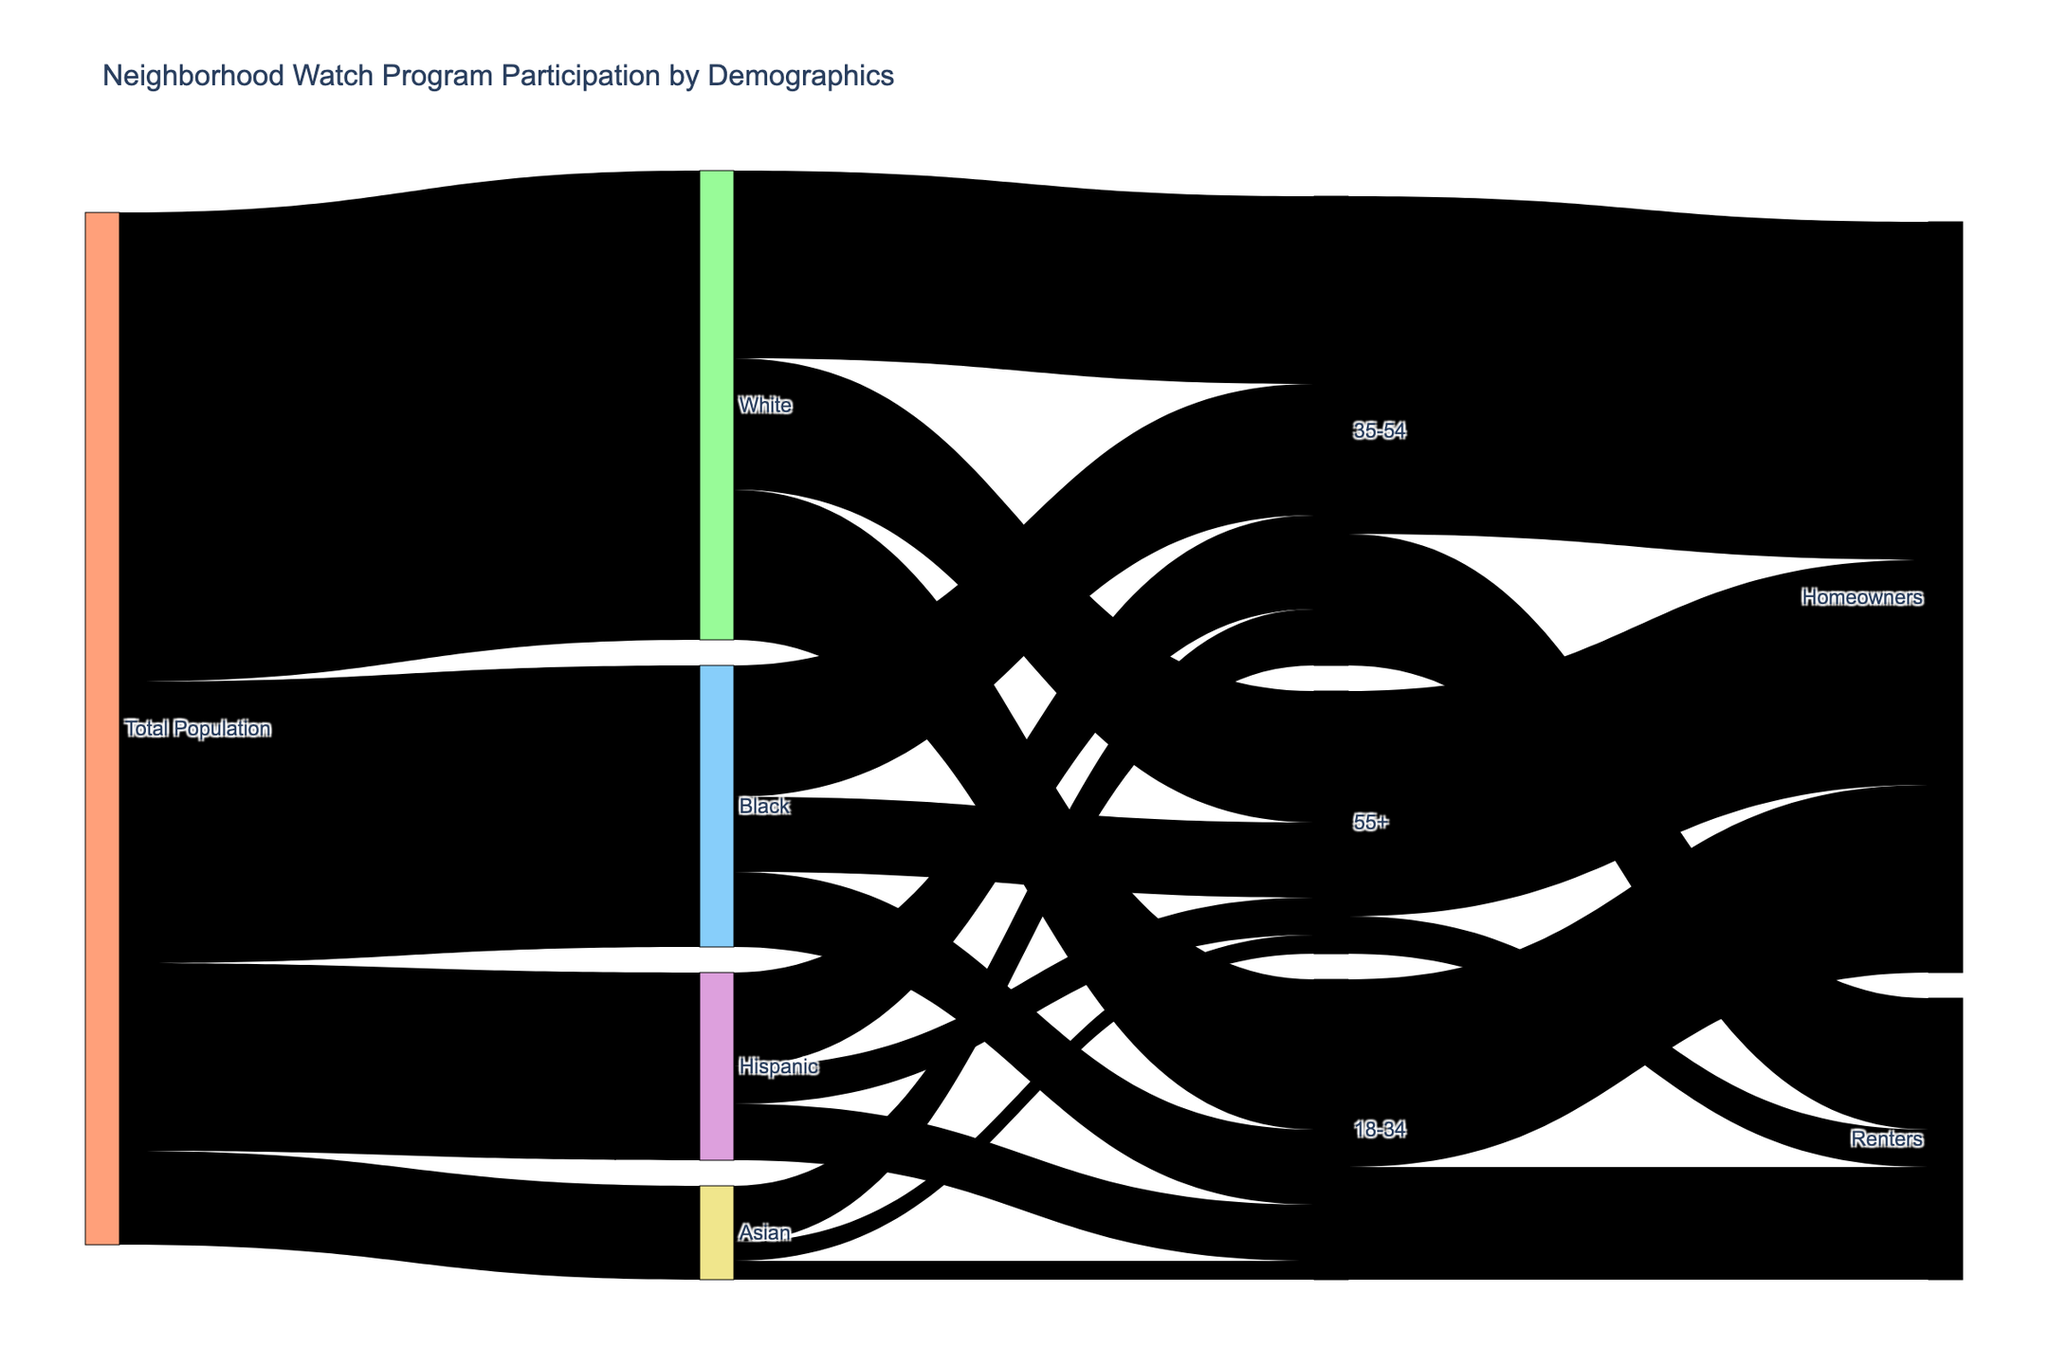Which demographic group has the highest total participation rate in the neighborhood watch program? To find the group with the highest participation rate, look for the demographic group with the largest total value flowing from the "Total Population" source node. The participation rates are: White (25), Black (15), Hispanic (10), and Asian (5).
Answer: White What is the combined participation rate for people aged 35-54? Add the participation rates of people aged 35-54 across all demographic categories. This includes White (10), Black (7), Hispanic (5), and Asian (3): 10 + 7 + 5 + 3.
Answer: 25 How many demographic groups are represented in the Sankey diagram? Count the unique demographic groups that appear in the figure: White, Black, Hispanic, and Asian.
Answer: 4 Which age group within the Black demographic has the lowest participation rate? Look at the participation rates of all age groups within the Black demographic: 18-34 (4), 35-54 (7), and 55+ (4). The lowest participation rate is 4.
Answer: 18-34 or 55+ How does the participation rate of Hispanic renters compare to Black renters? Compare the specific participation rates from the age groups with 'Renters': Hispanic renters (6) vs. Black renters (7).
Answer: Lower What is the total participation rate for homeowners aged 18-34? Sum the participation rates for homeowners in the 18-34 age group. In the given data, 18-34 homeowners have a participation rate of 10.
Answer: 10 What percentage of the Asian demographic's participation is from the 35-54 age group? Calculate the percentage by dividing the participation rate of the 35-54 age group by the total for Asians and multiplying by 100. Participation rates for Asians are: 18-34 (1), 35-54 (3), 55+ (1). The intermediate step is (3 / (1+3+1)) * 100.
Answer: 60% Which age group among the White demographic has the highest participation rate? Look at the participation rates for each age group in the White demographic: 18-34 (8), 35-54 (10), and 55+ (7). The highest is 10.
Answer: 35-54 What is the difference in the participation rates between White homeowners and renters in the 35-54 age group? Identify the participation rates for White homeowners (18) and renters (7) in the 35-54 age group and calculate the difference: 18 - 7.
Answer: 11 What is the average participation rate for people aged 55+ across all demographics? Calculate the average by summing the participation rates for 55+ age group across all demographics and dividing by the number of demographics: (7 + 4 + 2 + 1) / 4.
Answer: 3.5 